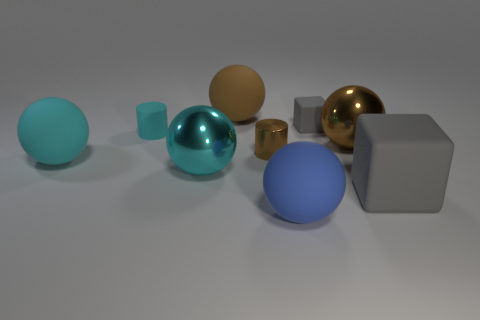Are there any other matte objects of the same shape as the blue thing?
Offer a very short reply. Yes. Is the size of the cyan matte cylinder the same as the cylinder that is in front of the cyan matte cylinder?
Your answer should be very brief. Yes. How many objects are either tiny cylinders that are behind the small brown object or big things behind the big blue rubber ball?
Give a very brief answer. 6. Is the number of matte things in front of the big brown rubber thing greater than the number of big yellow cubes?
Keep it short and to the point. Yes. What number of shiny balls have the same size as the cyan cylinder?
Keep it short and to the point. 0. There is a metal sphere left of the tiny rubber cube; is it the same size as the gray rubber object behind the large cyan metallic thing?
Make the answer very short. No. What size is the cyan metal ball that is in front of the small gray block?
Keep it short and to the point. Large. What size is the rubber object in front of the matte cube in front of the cyan matte cylinder?
Your answer should be very brief. Large. There is a brown object that is the same size as the brown matte ball; what is its material?
Give a very brief answer. Metal. Are there any brown rubber objects behind the brown matte ball?
Provide a short and direct response. No. 